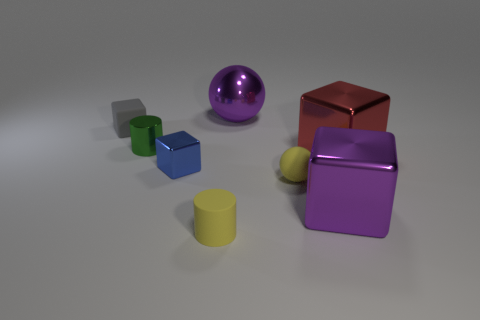Add 1 tiny green metallic things. How many objects exist? 9 Subtract all cylinders. How many objects are left? 6 Subtract all large red metal objects. Subtract all red things. How many objects are left? 6 Add 2 big blocks. How many big blocks are left? 4 Add 6 red cubes. How many red cubes exist? 7 Subtract 1 blue cubes. How many objects are left? 7 